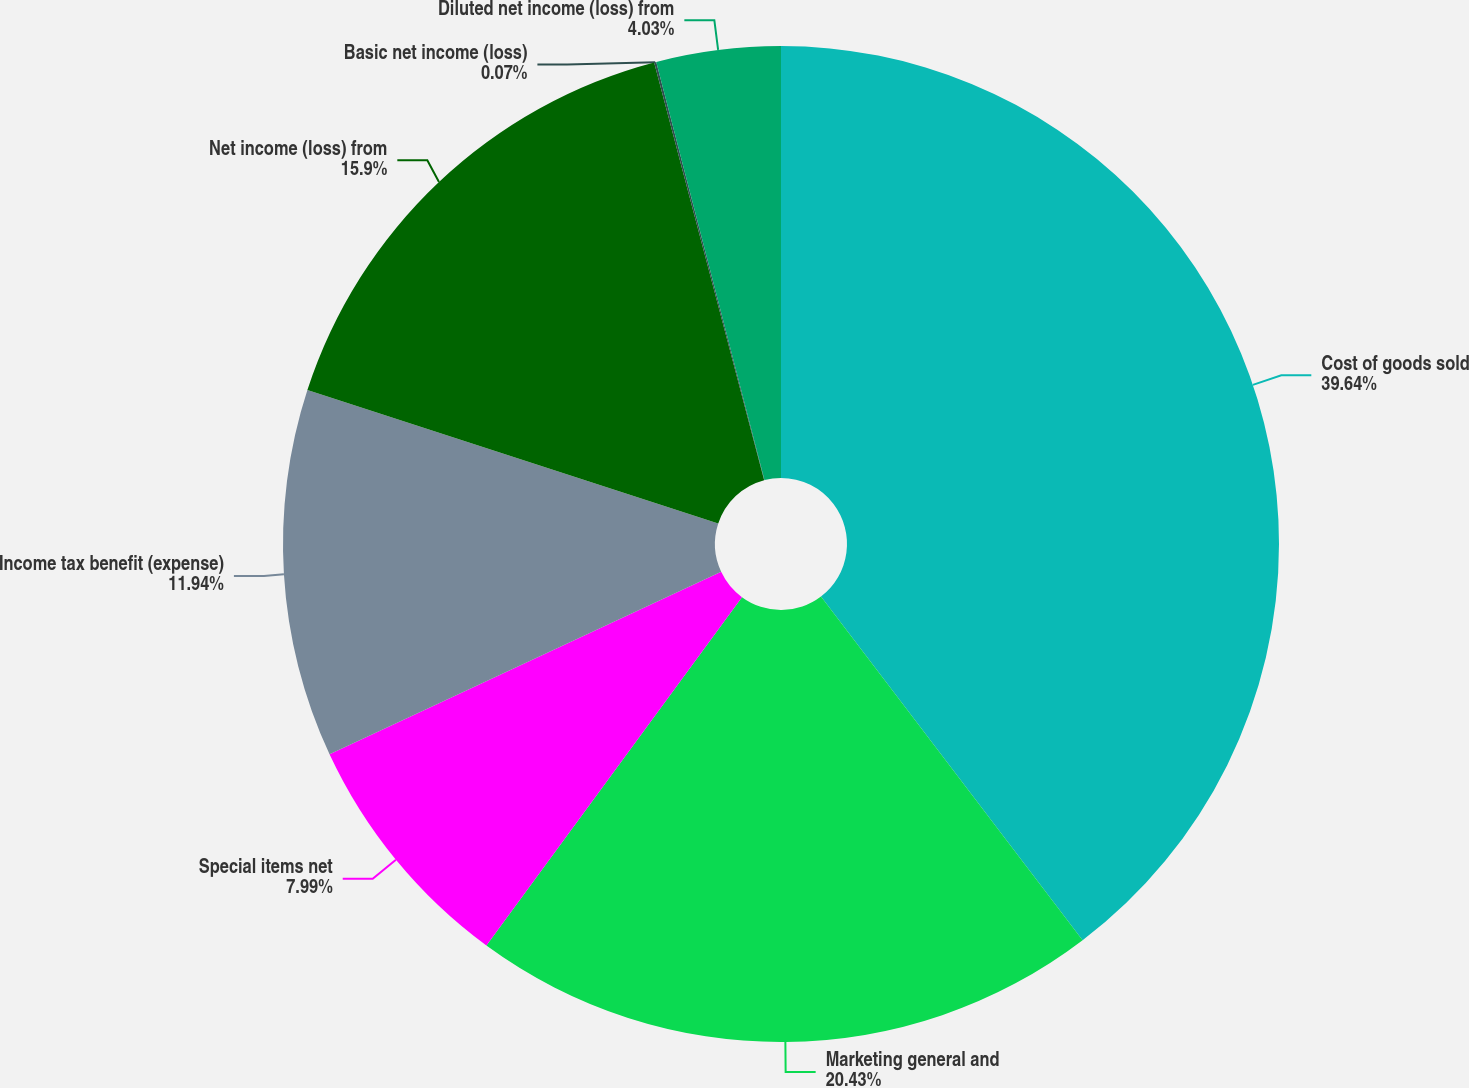Convert chart to OTSL. <chart><loc_0><loc_0><loc_500><loc_500><pie_chart><fcel>Cost of goods sold<fcel>Marketing general and<fcel>Special items net<fcel>Income tax benefit (expense)<fcel>Net income (loss) from<fcel>Basic net income (loss)<fcel>Diluted net income (loss) from<nl><fcel>39.65%<fcel>20.43%<fcel>7.99%<fcel>11.94%<fcel>15.9%<fcel>0.07%<fcel>4.03%<nl></chart> 